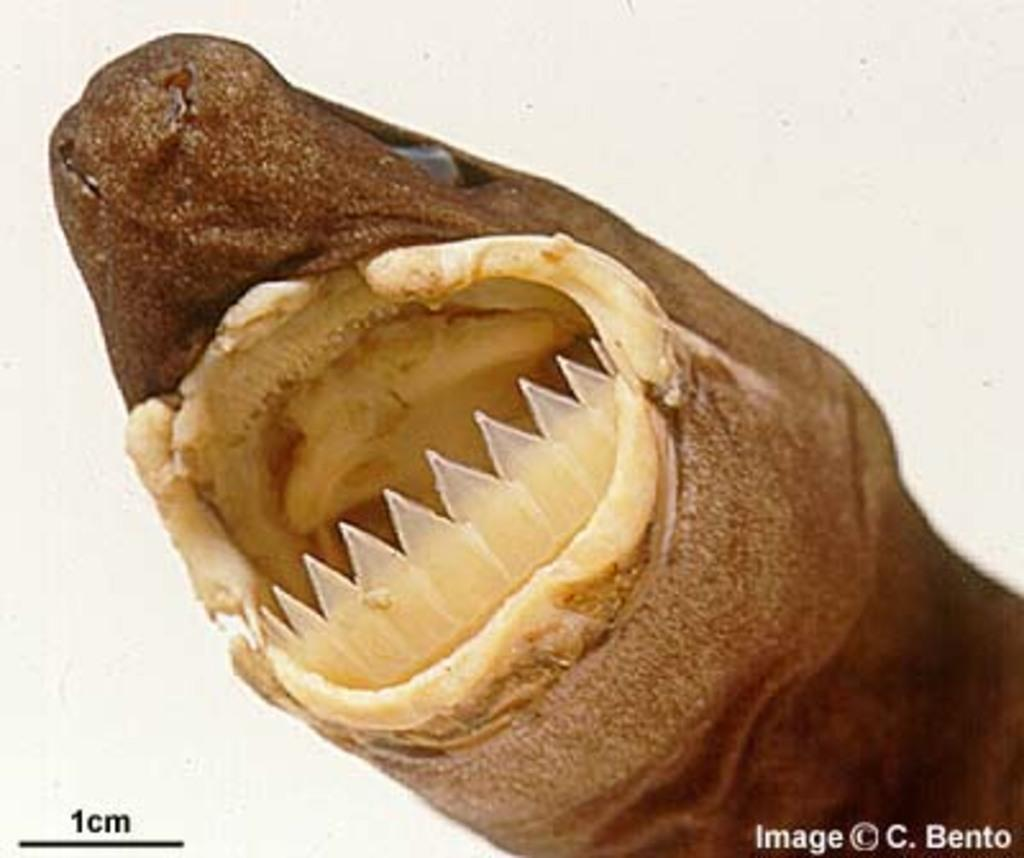What type of object is the main subject in the image? There is a toy animal in the image. What color is the background of the image? The background of the image is white. Can you describe any additional features of the image? There is a watermark on the image. What is the taste of the toy animal's toes in the image? Toys do not have a taste, and the image does not show the toy animal's toes. 